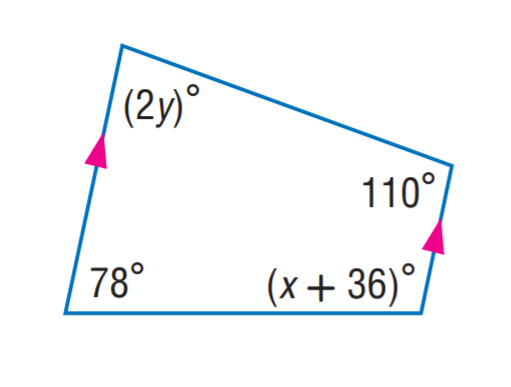Answer the mathemtical geometry problem and directly provide the correct option letter.
Question: Find x.
Choices: A: 35 B: 36 C: 66 D: 78 C 